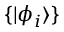Convert formula to latex. <formula><loc_0><loc_0><loc_500><loc_500>\{ | \phi _ { i } \rangle \}</formula> 